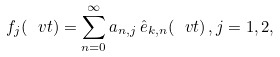<formula> <loc_0><loc_0><loc_500><loc_500>f _ { j } ( \ v t ) = \sum _ { n = 0 } ^ { \infty } a _ { n , j } \, \hat { e } _ { k , n } ( \ v t ) \, , j = 1 , 2 ,</formula> 